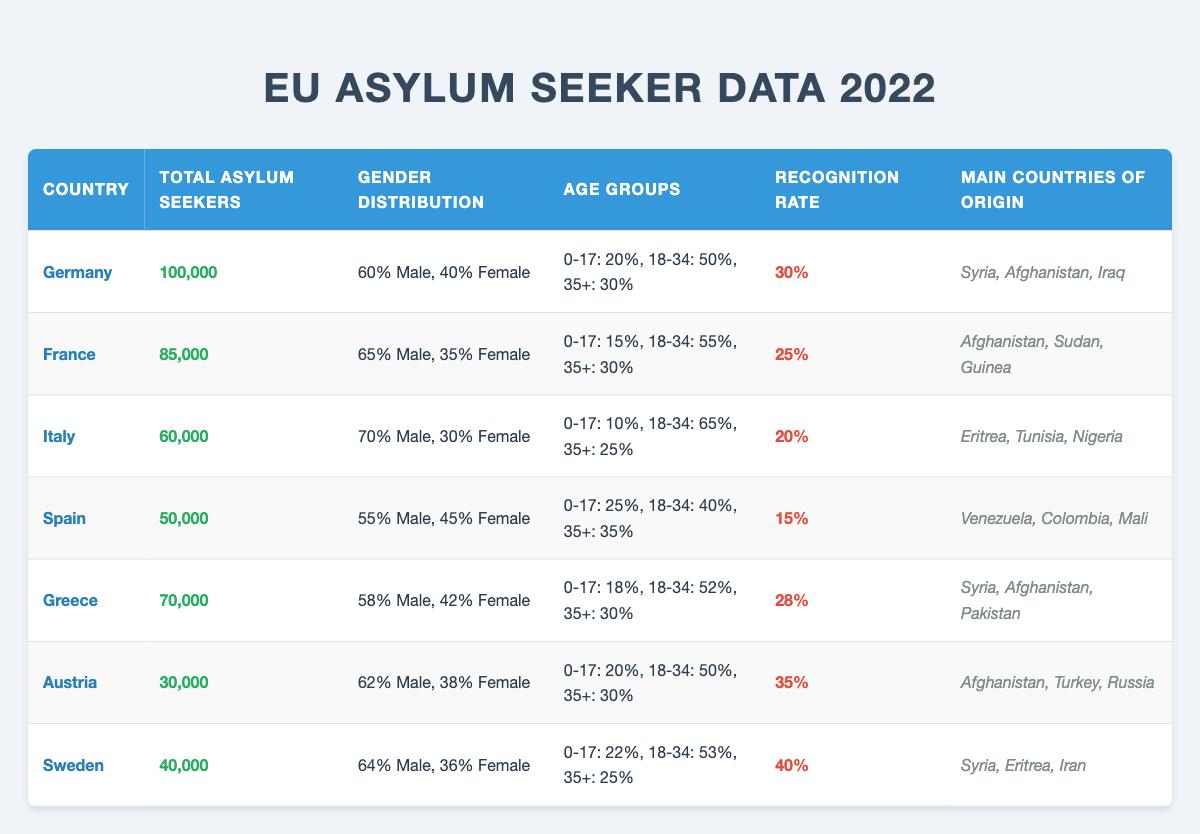What is the total number of asylum seekers in Germany? The table specifies that Germany had 100,000 total asylum seekers in 2022.
Answer: 100,000 What percentage of asylum seekers in France are male? According to the table, France has 65% male asylum seekers.
Answer: 65% Which country has the highest recognition rate? By comparing the recognition rates, Sweden has the highest at 40%.
Answer: Sweden What is the age percentage of asylum seekers aged 0-17 in Spain? The table states that 25% of asylum seekers in Spain are aged 0-17.
Answer: 25% What is the total number of asylum seekers in Italy and Spain combined? To find the total, we add the asylum seekers: Italy (60,000) + Spain (50,000) equals 110,000.
Answer: 110,000 Do more asylum seekers come from Afghanistan or Syria in Greece? In Greece, the main countries of origin listed are Syria, Afghanistan, and Pakistan. To determine which has more, it requires understanding external data not in this table, but both are present. Thus, we cannot ascertain a definite answer.
Answer: Not determinable from this data What is the average recognition rate of asylum seekers across all mentioned countries? The recognition rates are: Germany (30%), France (25%), Italy (20%), Spain (15%), Greece (28%), Austria (35%), and Sweden (40%). Summing these gives 30 + 25 + 20 + 15 + 28 + 35 + 40 = 193. There are 7 countries, so the average will be 193/7 ≈ 27.57%.
Answer: Approximately 27.57% How many asylum seekers are there in Austria compared to Sweden? Austria has 30,000 total asylum seekers, while Sweden has 40,000. Therefore, Sweden has more, specifically 10,000 more.
Answer: Sweden has 10,000 more Which country's asylum seekers have the highest percentage in the age group of 18-34? In Italy, 65% of asylum seekers fall within the 18-34 age group, which is the highest compared to other countries in the table.
Answer: Italy Is the female percentage of asylum seekers higher in Greece than in France? The female percentage in Greece is 42%, while in France it is 35%. Thus, Greece has a higher female percentage.
Answer: Yes Where do most asylum seekers in Italy originate from? The main countries of origin listed for Italy are Eritrea, Tunisia, and Nigeria. Thus, Eritrea is one of the primary sources.
Answer: Eritrea, Tunisia, Nigeria 